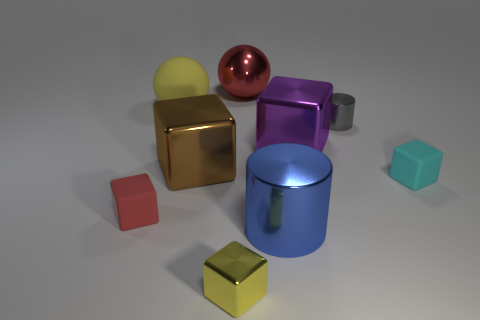Do the red thing that is on the left side of the red metallic sphere and the large metal ball have the same size?
Offer a terse response. No. What is the color of the large sphere that is on the left side of the big red ball?
Make the answer very short. Yellow. How many objects are there?
Your response must be concise. 9. The small gray thing that is the same material as the large blue thing is what shape?
Your answer should be compact. Cylinder. There is a big metallic thing that is behind the small cylinder; is it the same color as the cylinder that is in front of the small cyan rubber object?
Provide a short and direct response. No. Is the number of small rubber blocks that are in front of the tiny yellow metal cube the same as the number of small purple cylinders?
Your answer should be very brief. Yes. There is a large purple thing; what number of small shiny cylinders are to the left of it?
Keep it short and to the point. 0. The blue metallic thing is what size?
Give a very brief answer. Large. What is the color of the ball that is made of the same material as the big brown block?
Your answer should be compact. Red. How many brown metal blocks are the same size as the yellow metal object?
Your answer should be compact. 0. 